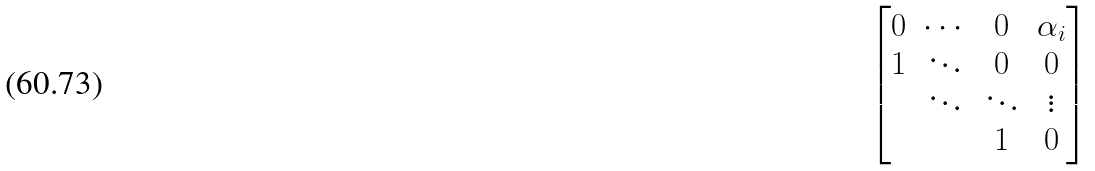<formula> <loc_0><loc_0><loc_500><loc_500>\begin{bmatrix} 0 & \cdots & 0 & \alpha _ { i } \\ 1 & \ddots & 0 & 0 \\ & \ddots & \ddots & \vdots \\ & & 1 & 0 \end{bmatrix}</formula> 